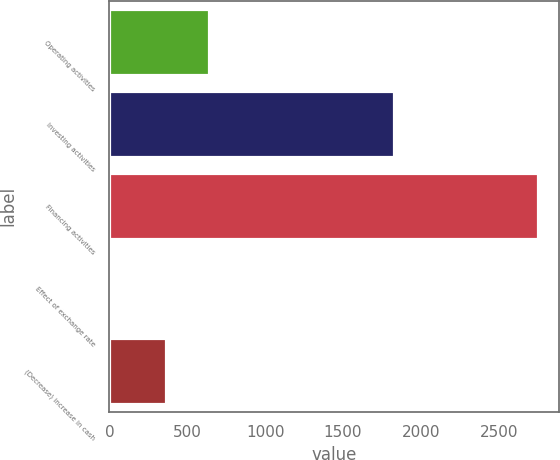Convert chart. <chart><loc_0><loc_0><loc_500><loc_500><bar_chart><fcel>Operating activities<fcel>Investing activities<fcel>Financing activities<fcel>Effect of exchange rate<fcel>(Decrease) increase in cash<nl><fcel>637<fcel>1830<fcel>2751<fcel>1<fcel>362<nl></chart> 